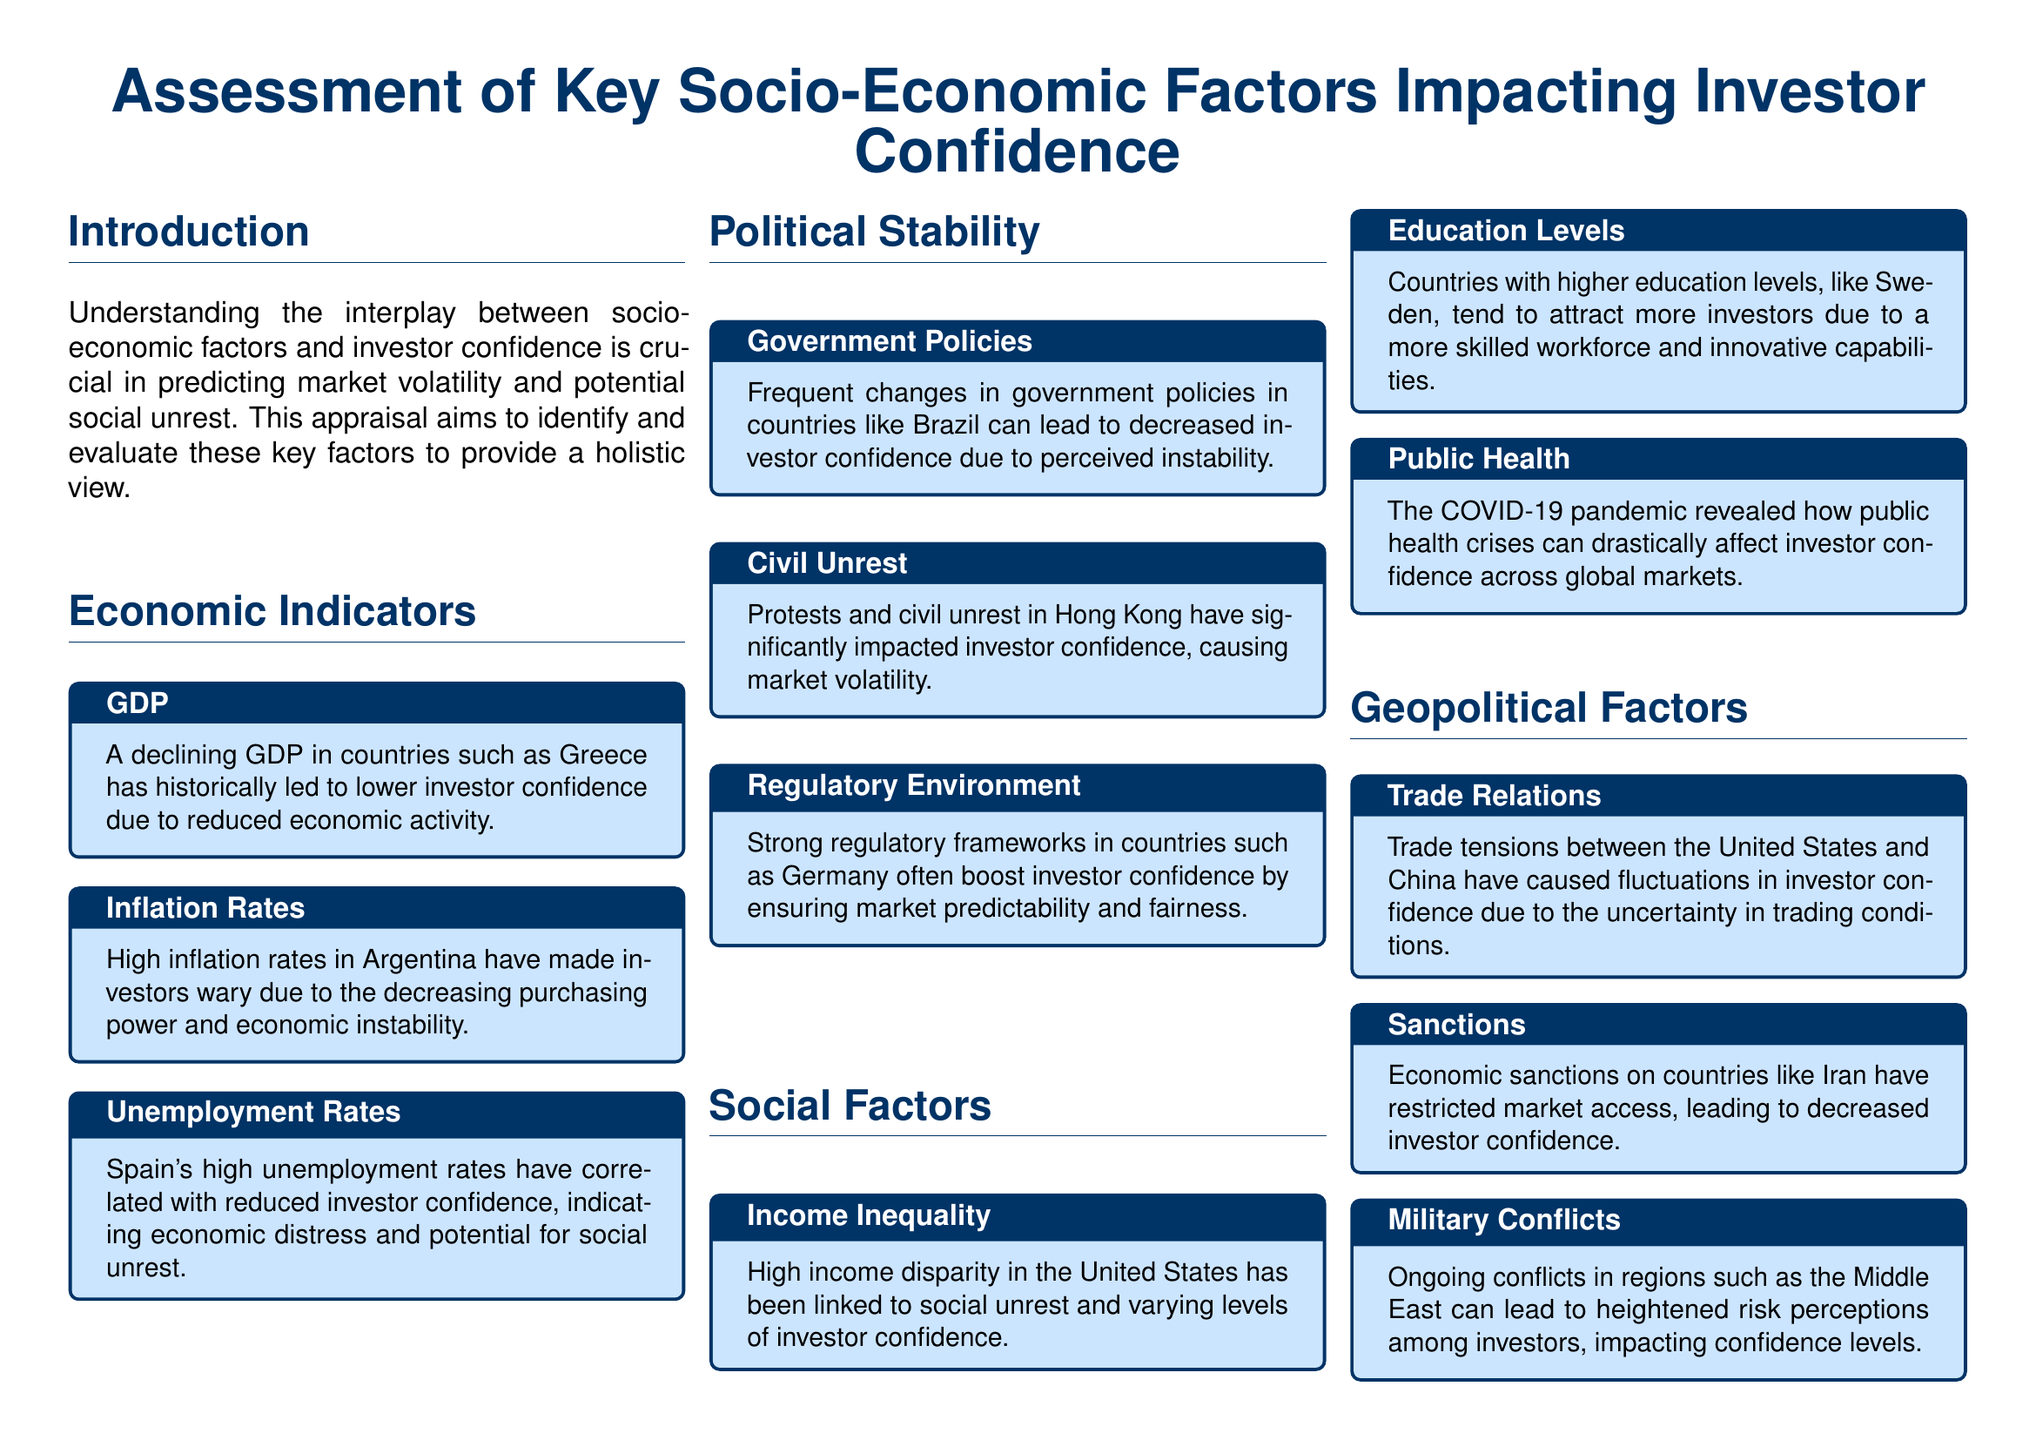what is the title of the document? The title is found in the header of the document, which outlines the subject matter clearly.
Answer: Assessment of Key Socio-Economic Factors Impacting Investor Confidence what socio-economic factor correlates with declining GDP? The text specifies a socio-economic factor that is linked to declining GDP in certain countries, contributing to investor sentiment.
Answer: GDP which country has high inflation rates affecting investor confidence? The document mentions a specific country known for its inflation issues impacting investor sentiment.
Answer: Argentina what has been indicated by high unemployment rates in Spain? The document references a socio-economic concern related to high unemployment that affects investor confidence.
Answer: Economic distress which geopolitical factor is linked to trade tensions? The document identifies a significant geopolitical factor that can fluctuate investor confidence due to international relations.
Answer: Trade Relations what type of regulatory environment boosts investor confidence? The appraisal highlights a feature of a regulatory framework that generally enhances investor trust in markets.
Answer: Strong regulatory frameworks which country is noted for its high income inequality? The document provides a specific example of a country characterized by significant income disparity affecting social stability.
Answer: United States what crisis affected investor confidence during 2020? A major global event is highlighted in the document that had severe impacts on market confidence throughout that year.
Answer: COVID-19 pandemic which country exhibits a high education level attracting investors? A specific country is mentioned as having a high level of education, influencing its economic appeal to investors.
Answer: Sweden what is a significant outcome of civil unrest mentioned in the document? The appraisal describes a particular impact of civil unrest on the financial landscape of affected regions.
Answer: Market volatility 